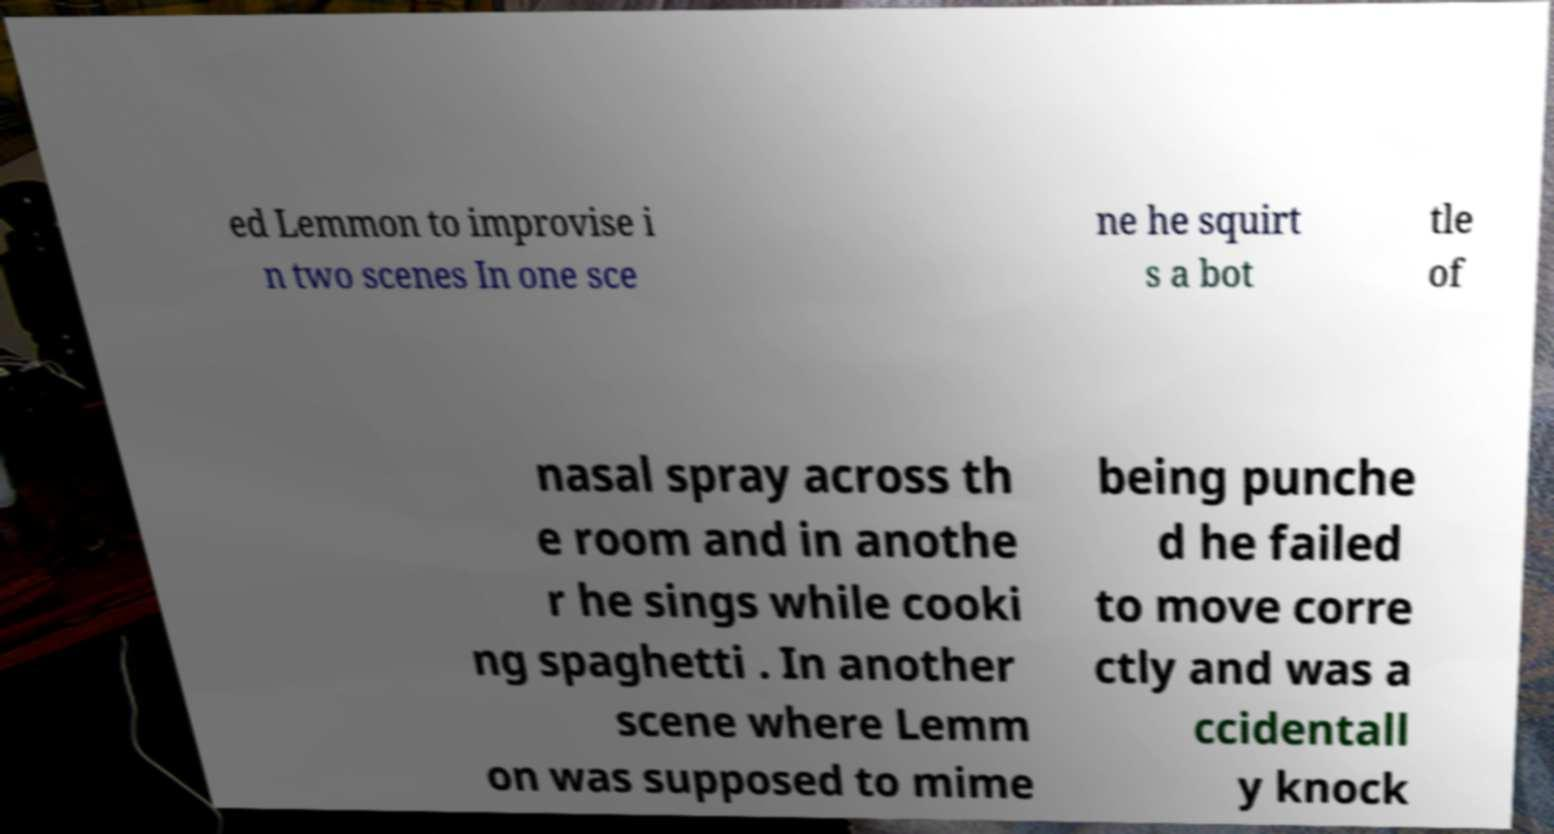Please read and relay the text visible in this image. What does it say? ed Lemmon to improvise i n two scenes In one sce ne he squirt s a bot tle of nasal spray across th e room and in anothe r he sings while cooki ng spaghetti . In another scene where Lemm on was supposed to mime being punche d he failed to move corre ctly and was a ccidentall y knock 